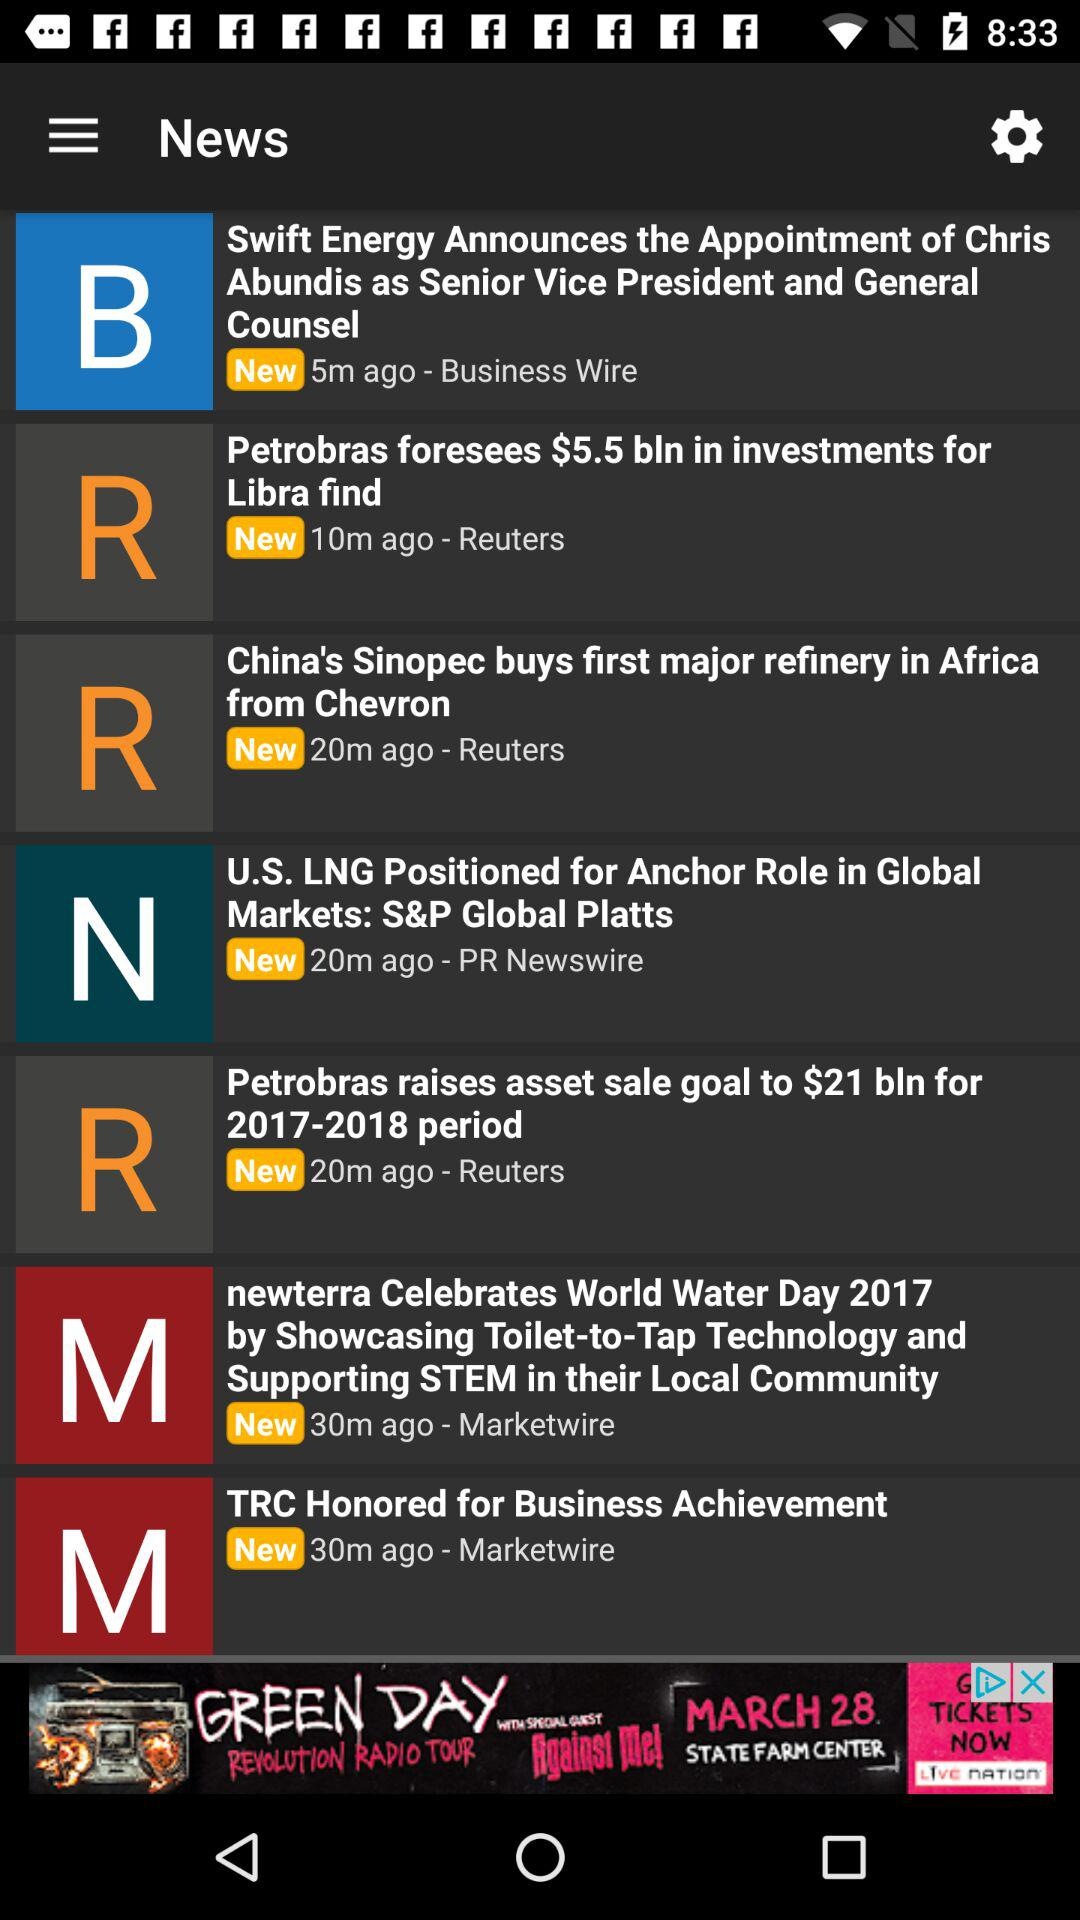Which news was broadcast 10 minutes ago? The news "Petrobras foresees $5.5 bln in investments for Libra find" was broadcast 10 minutes ago. 